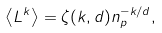Convert formula to latex. <formula><loc_0><loc_0><loc_500><loc_500>\left < L ^ { k } \right > = \zeta ( k , d ) n _ { p } ^ { - k / d } ,</formula> 